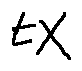Convert formula to latex. <formula><loc_0><loc_0><loc_500><loc_500>t X</formula> 